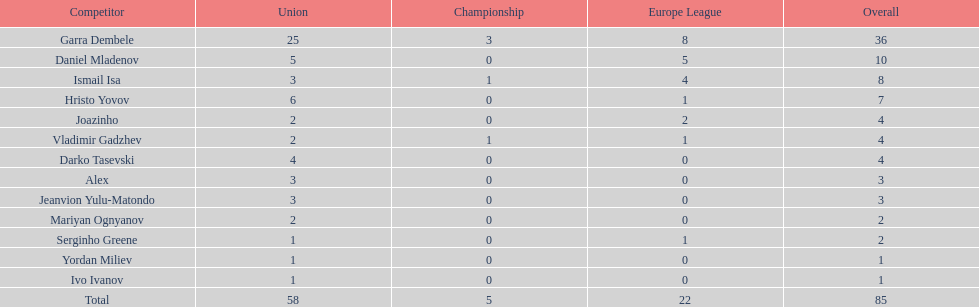How many of the athletes did not score any goals in the cup? 10. 